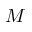<formula> <loc_0><loc_0><loc_500><loc_500>M</formula> 